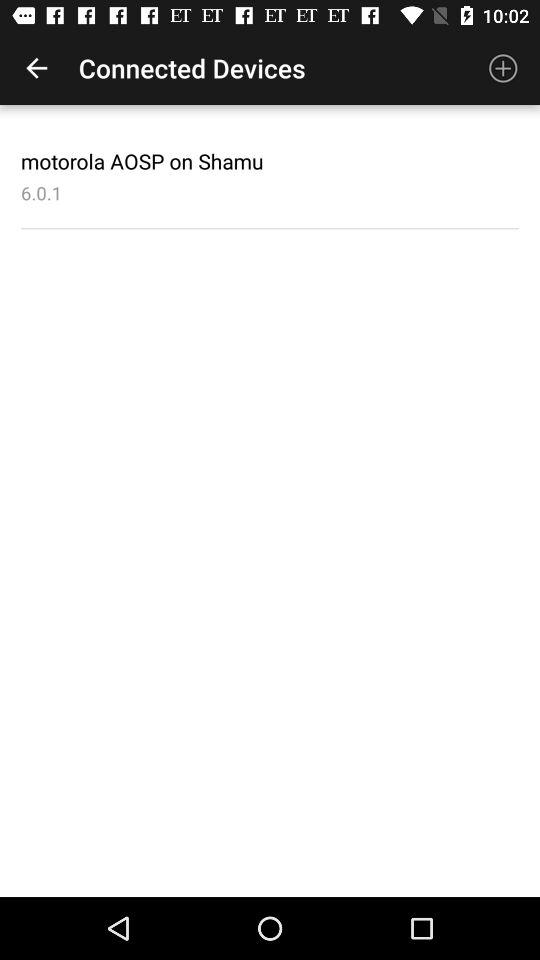Where are the devices connected to?
When the provided information is insufficient, respond with <no answer>. <no answer> 